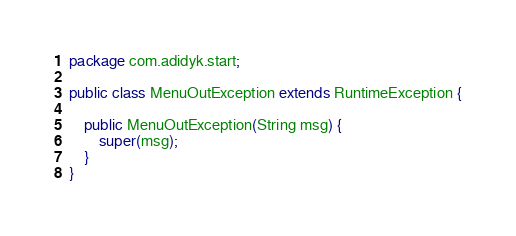<code> <loc_0><loc_0><loc_500><loc_500><_Java_>package com.adidyk.start;

public class MenuOutException extends RuntimeException {

    public MenuOutException(String msg) {
        super(msg);
    }
}
</code> 